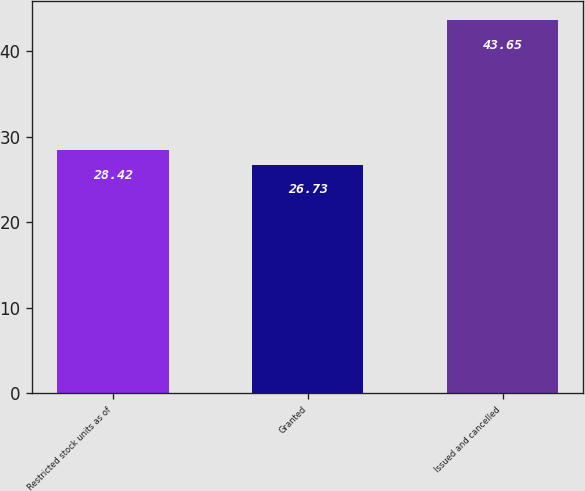Convert chart. <chart><loc_0><loc_0><loc_500><loc_500><bar_chart><fcel>Restricted stock units as of<fcel>Granted<fcel>Issued and cancelled<nl><fcel>28.42<fcel>26.73<fcel>43.65<nl></chart> 